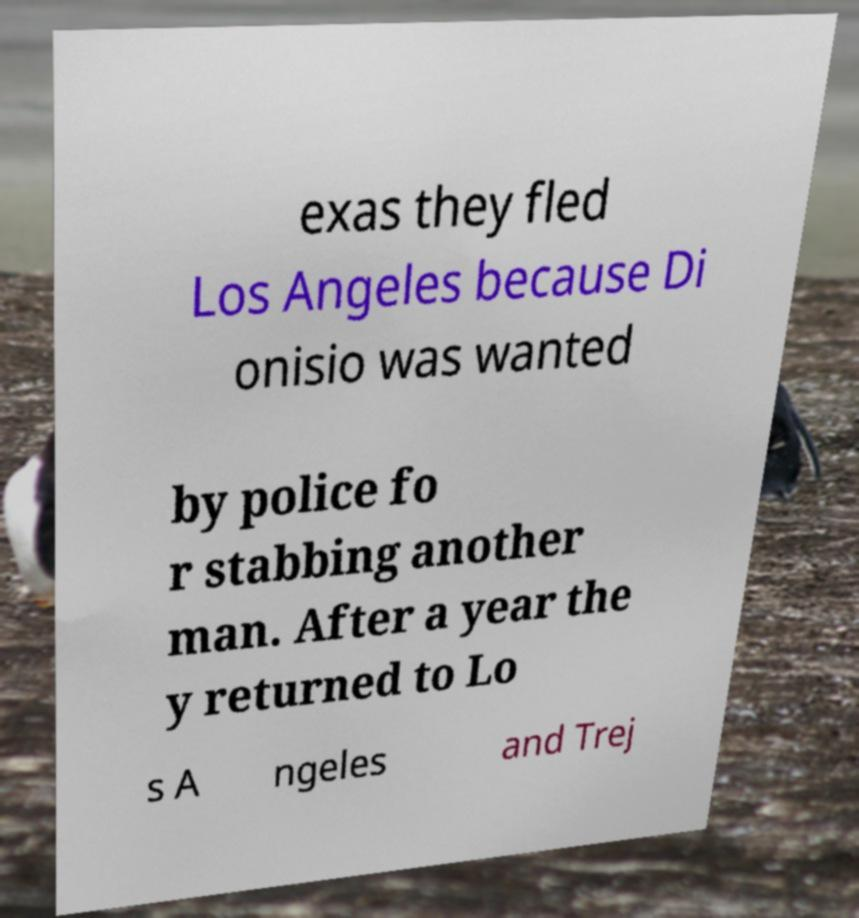What messages or text are displayed in this image? I need them in a readable, typed format. exas they fled Los Angeles because Di onisio was wanted by police fo r stabbing another man. After a year the y returned to Lo s A ngeles and Trej 